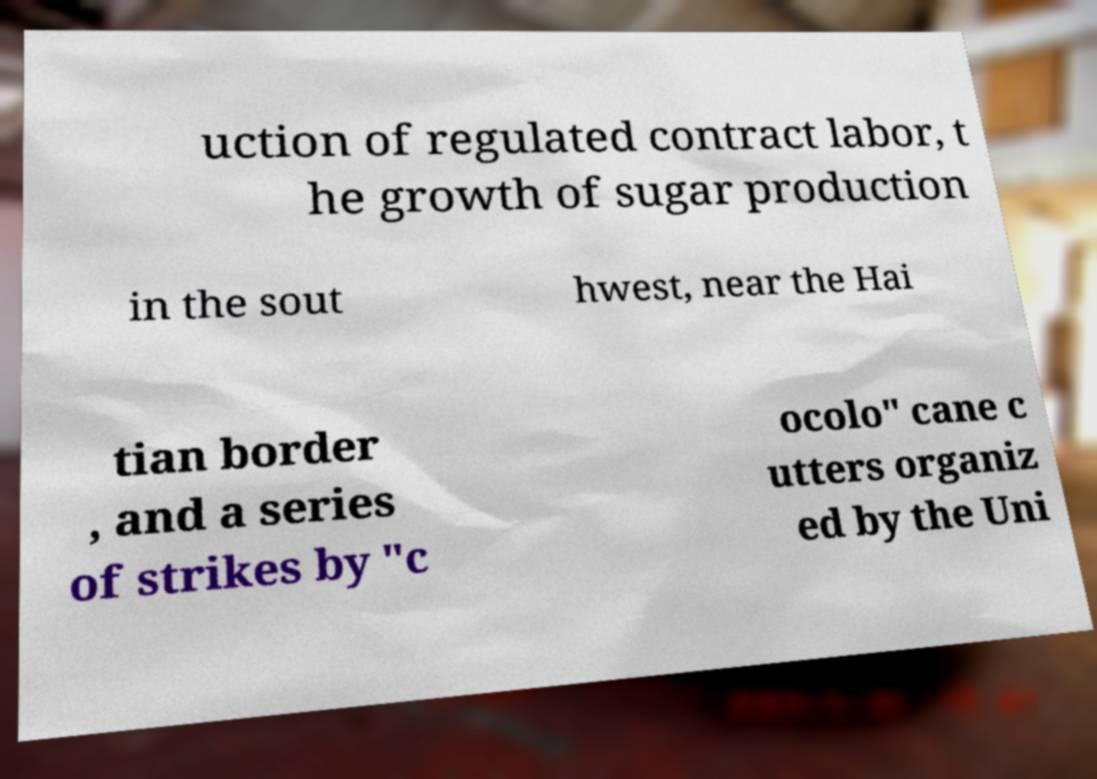Please read and relay the text visible in this image. What does it say? uction of regulated contract labor, t he growth of sugar production in the sout hwest, near the Hai tian border , and a series of strikes by "c ocolo" cane c utters organiz ed by the Uni 